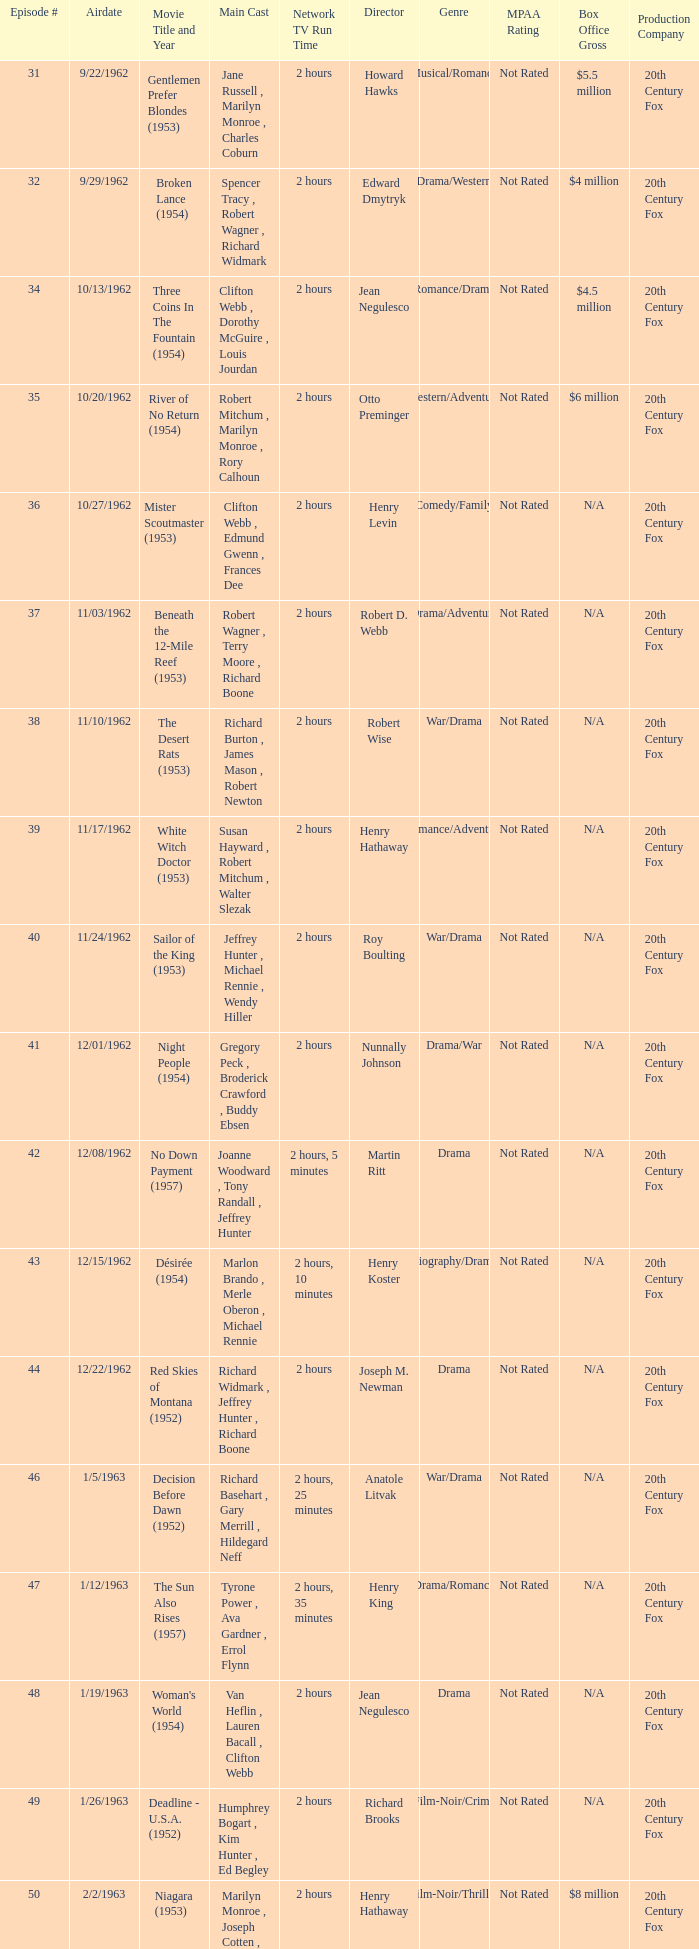How many runtimes does episode 53 have? 1.0. 